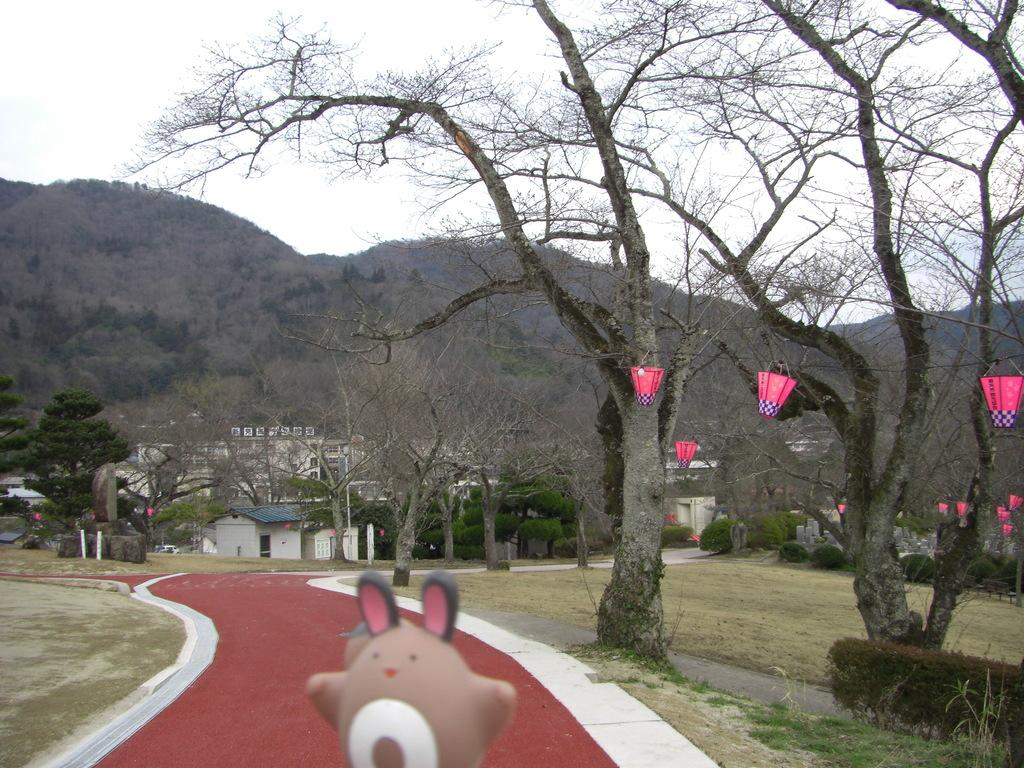What type of vegetation can be seen in the image? There are trees, grass, and plants in the image. What object is present that might be used for play? There is a toy in the image. What type of illumination is visible in the image? There are lights in the image. What structures can be seen in the background of the image? In the background, there are buildings, a house, and trees. What part of the natural environment is visible in the image? The sky is visible in the background of the image. Can you tell me how many umbrellas are open in the image? There are no umbrellas present in the image. What type of frog can be seen sitting on the toy in the image? There is no frog present in the image; only a toy is visible. 